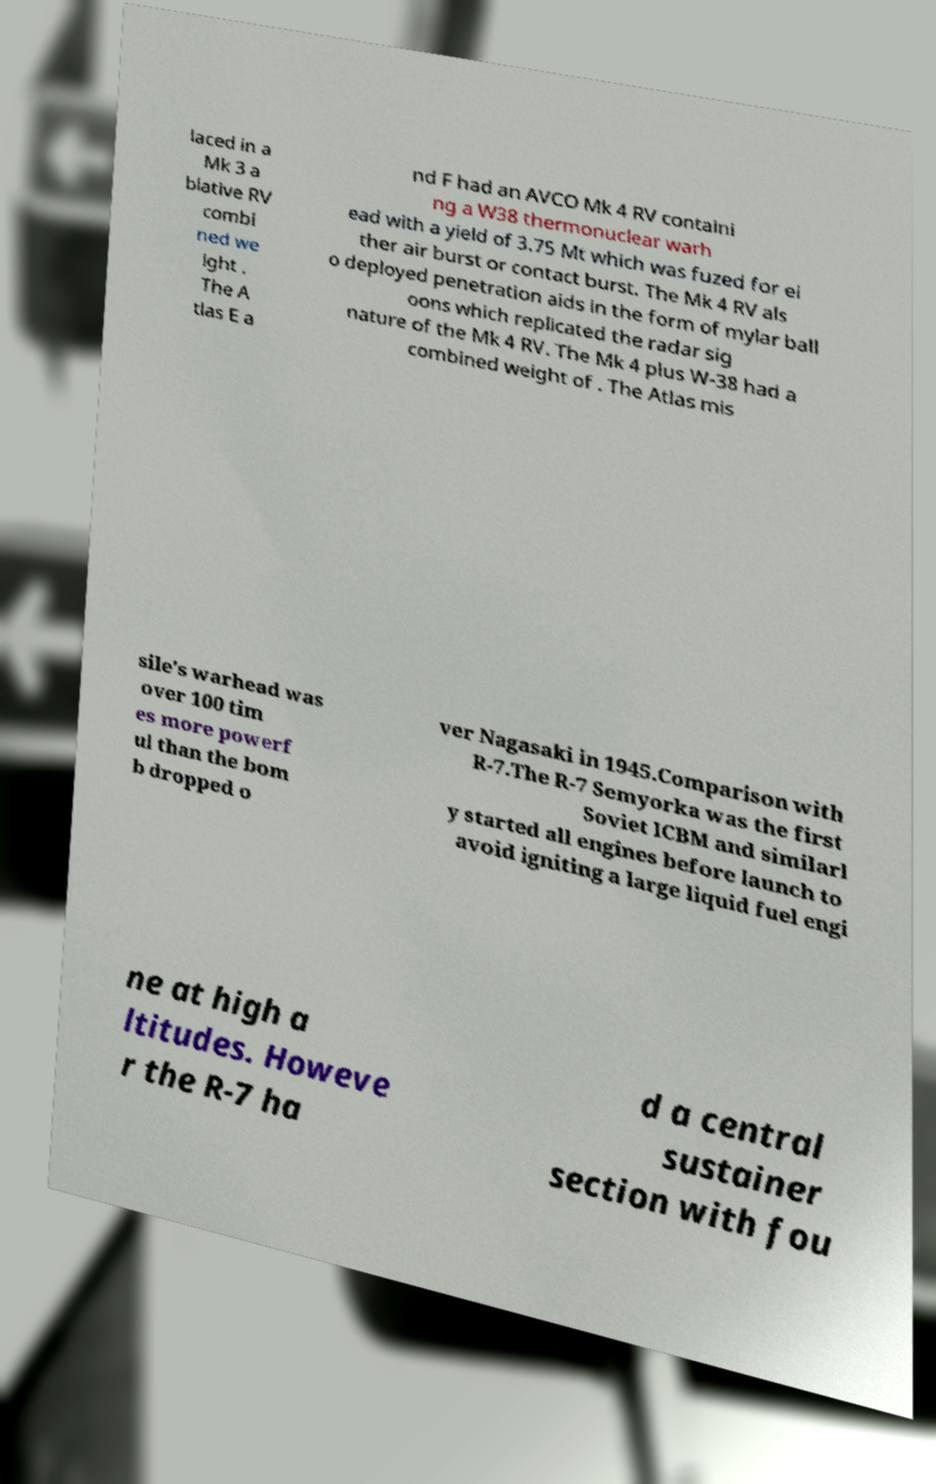I need the written content from this picture converted into text. Can you do that? laced in a Mk 3 a blative RV combi ned we ight . The A tlas E a nd F had an AVCO Mk 4 RV containi ng a W38 thermonuclear warh ead with a yield of 3.75 Mt which was fuzed for ei ther air burst or contact burst. The Mk 4 RV als o deployed penetration aids in the form of mylar ball oons which replicated the radar sig nature of the Mk 4 RV. The Mk 4 plus W-38 had a combined weight of . The Atlas mis sile's warhead was over 100 tim es more powerf ul than the bom b dropped o ver Nagasaki in 1945.Comparison with R-7.The R-7 Semyorka was the first Soviet ICBM and similarl y started all engines before launch to avoid igniting a large liquid fuel engi ne at high a ltitudes. Howeve r the R-7 ha d a central sustainer section with fou 